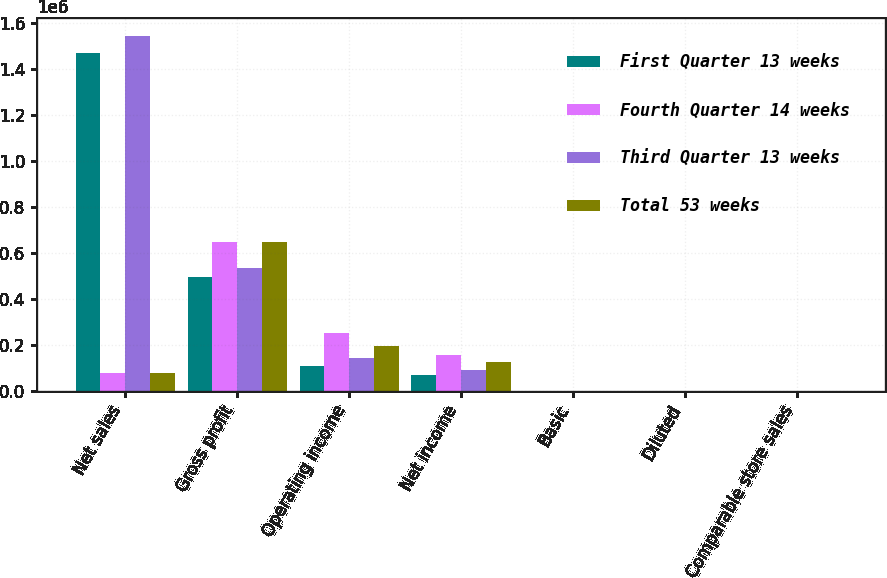Convert chart. <chart><loc_0><loc_0><loc_500><loc_500><stacked_bar_chart><ecel><fcel>Net sales<fcel>Gross profit<fcel>Operating income<fcel>Net income<fcel>Basic<fcel>Diluted<fcel>Comparable store sales<nl><fcel>First Quarter 13 weeks<fcel>1.4678e+06<fcel>494444<fcel>108195<fcel>67668<fcel>0.51<fcel>0.5<fcel>4.9<nl><fcel>Fourth Quarter 14 weeks<fcel>78556<fcel>649222<fcel>249249<fcel>156425<fcel>1.17<fcel>1.16<fcel>0.5<nl><fcel>Third Quarter 13 weeks<fcel>1.54271e+06<fcel>535274<fcel>142020<fcel>89444<fcel>0.67<fcel>0.67<fcel>0.6<nl><fcel>Total 53 weeks<fcel>78556<fcel>646262<fcel>194616<fcel>123583<fcel>0.94<fcel>0.94<fcel>3.1<nl></chart> 